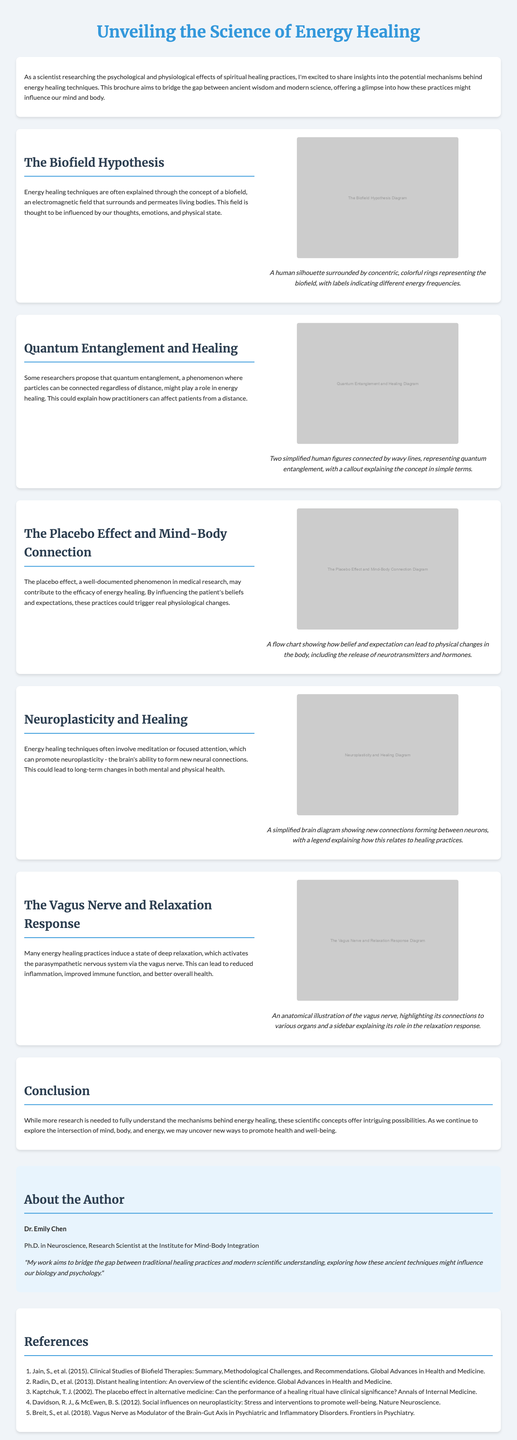What is the title of the brochure? The title is found at the beginning of the document, which states the main focus of the content.
Answer: Unveiling the Science of Energy Healing Who is the author of the brochure? The author's name is explicitly mentioned in the "About the Author" section of the document.
Answer: Dr. Emily Chen What does the section on the placebo effect discuss? This section indicates the psychological influence on healing practices and is mentioned under the corresponding title.
Answer: Mind-Body Connection Which nerve is highlighted in the section about relaxation? The specific nerve mentioned in relation to the relaxation response is stated in the document.
Answer: Vagus Nerve What concept explains the idea that practitioners can affect patients from a distance? The document provides a technical term that describes this phenomenon in the context of energy healing.
Answer: Quantum Entanglement What do energy healing techniques influence according to the brochure? A section describes factors that these techniques might affect, linking them to overall health.
Answer: Mind and Body Which scientific concept involves the brain's ability to form new neural connections? This term is discussed in relation to energy healing practices and mentioned in the corresponding section.
Answer: Neuroplasticity What type of diagram accompanies the section on the biofield hypothesis? The document specifies the visual representation used to illustrate this concept.
Answer: Human silhouette surrounded by concentric, colorful rings How does the brochure conclude regarding energy healing research? The conclusion summarizes the current understanding and future direction of the research.
Answer: More research is needed 